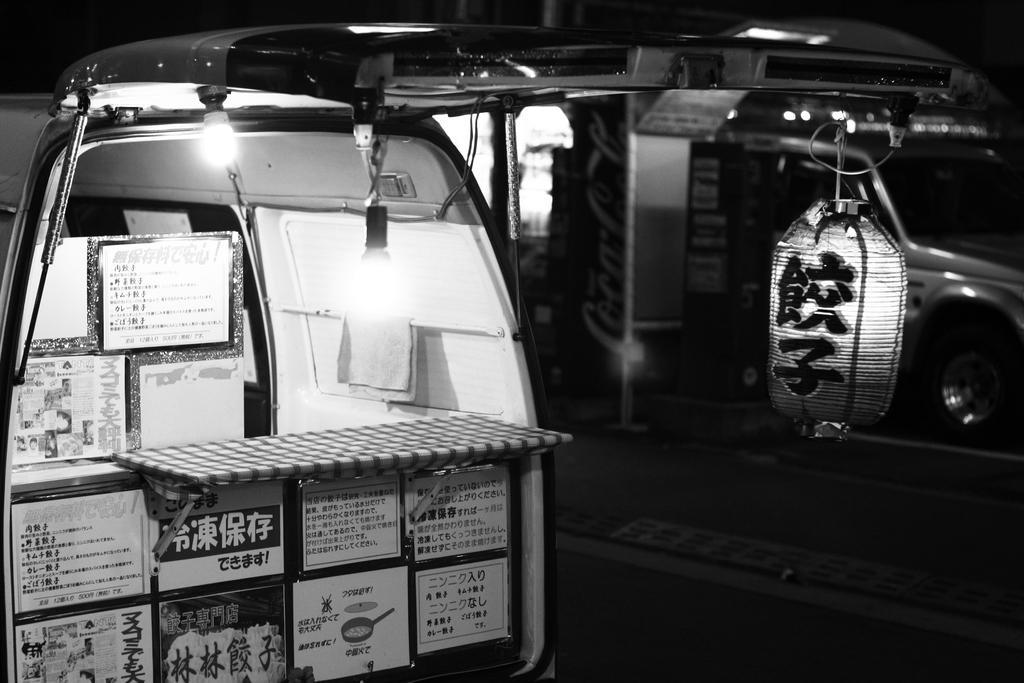How would you summarize this image in a sentence or two? In this picture we can see inside of the vehicle, in which we can see some boxes are placed, we can see some lights. 